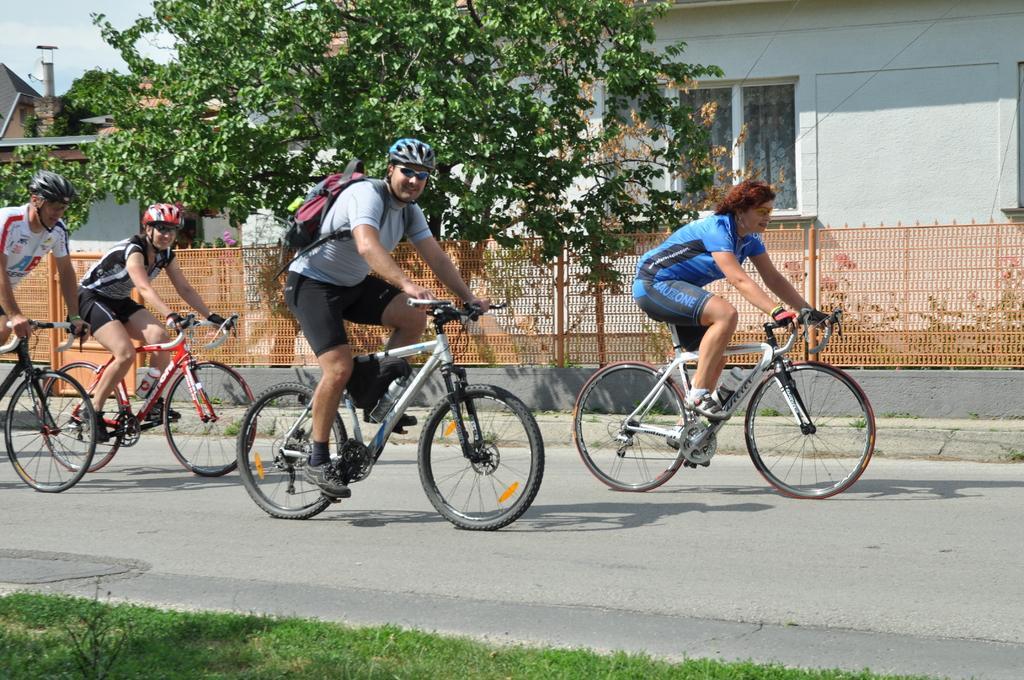How would you summarize this image in a sentence or two? This is an outside view. Here I can see few people are riding their bicycles on the road. On the bottom of the image I can see the grass. In the background there is a tree and a building. 